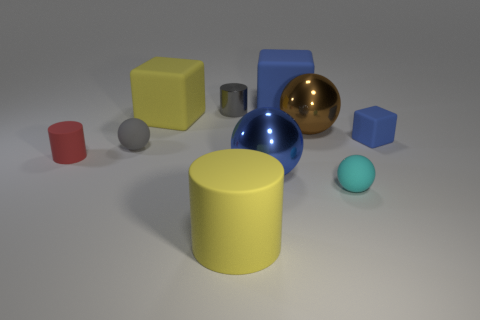Is the number of tiny gray objects in front of the tiny gray matte object greater than the number of big blue spheres right of the cyan thing?
Make the answer very short. No. What is the big yellow object behind the big brown metallic ball made of?
Provide a short and direct response. Rubber. Is the shape of the large blue matte thing the same as the tiny gray object behind the big yellow block?
Your response must be concise. No. There is a gray thing behind the blue block right of the tiny cyan sphere; how many big brown things are in front of it?
Provide a short and direct response. 1. The other large metal thing that is the same shape as the brown thing is what color?
Ensure brevity in your answer.  Blue. Is there anything else that is the same shape as the big brown shiny thing?
Your response must be concise. Yes. How many spheres are tiny yellow shiny things or tiny shiny objects?
Your response must be concise. 0. What shape is the tiny gray shiny object?
Your response must be concise. Cylinder. Are there any blue rubber cubes behind the tiny gray cylinder?
Your answer should be compact. Yes. Is the gray sphere made of the same material as the big block that is behind the small gray cylinder?
Your answer should be compact. Yes. 